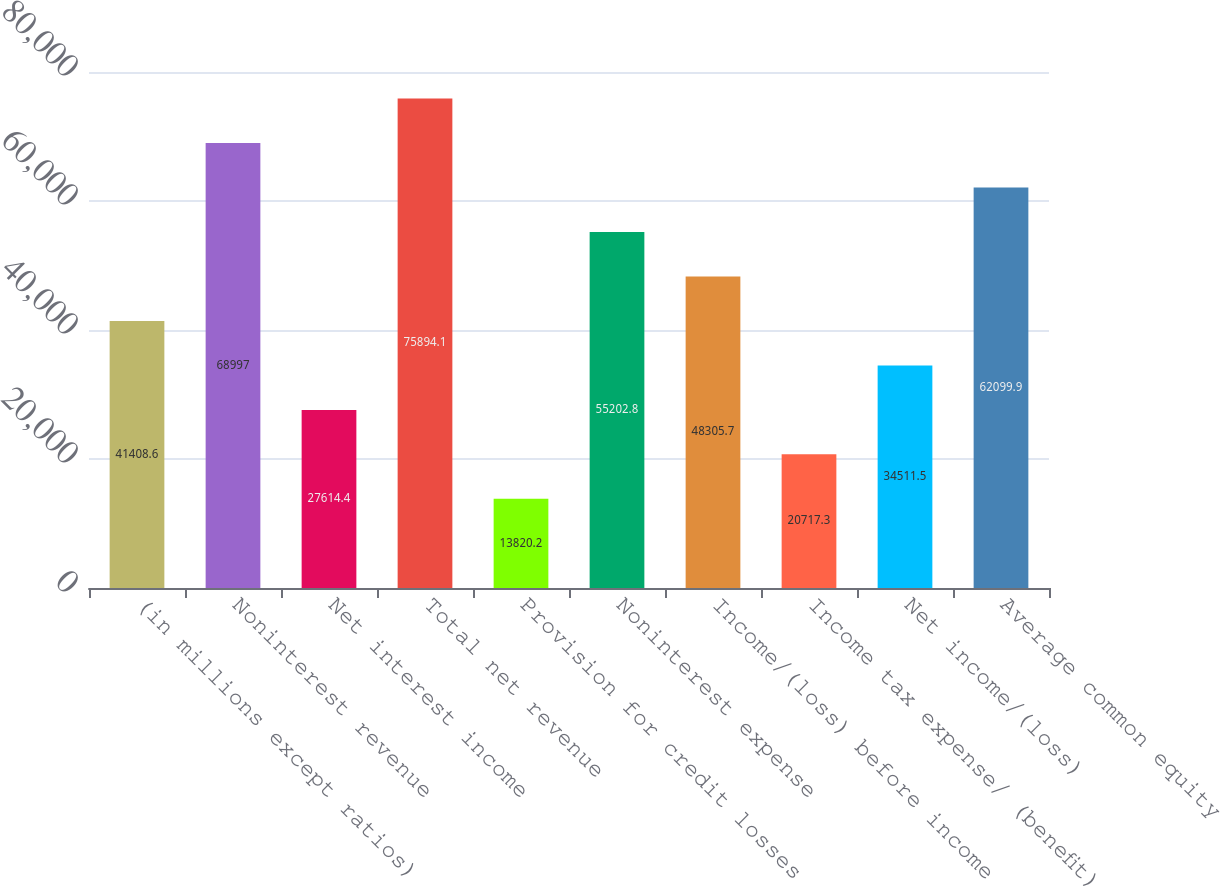<chart> <loc_0><loc_0><loc_500><loc_500><bar_chart><fcel>(in millions except ratios)<fcel>Noninterest revenue<fcel>Net interest income<fcel>Total net revenue<fcel>Provision for credit losses<fcel>Noninterest expense<fcel>Income/(loss) before income<fcel>Income tax expense/ (benefit)<fcel>Net income/(loss)<fcel>Average common equity<nl><fcel>41408.6<fcel>68997<fcel>27614.4<fcel>75894.1<fcel>13820.2<fcel>55202.8<fcel>48305.7<fcel>20717.3<fcel>34511.5<fcel>62099.9<nl></chart> 